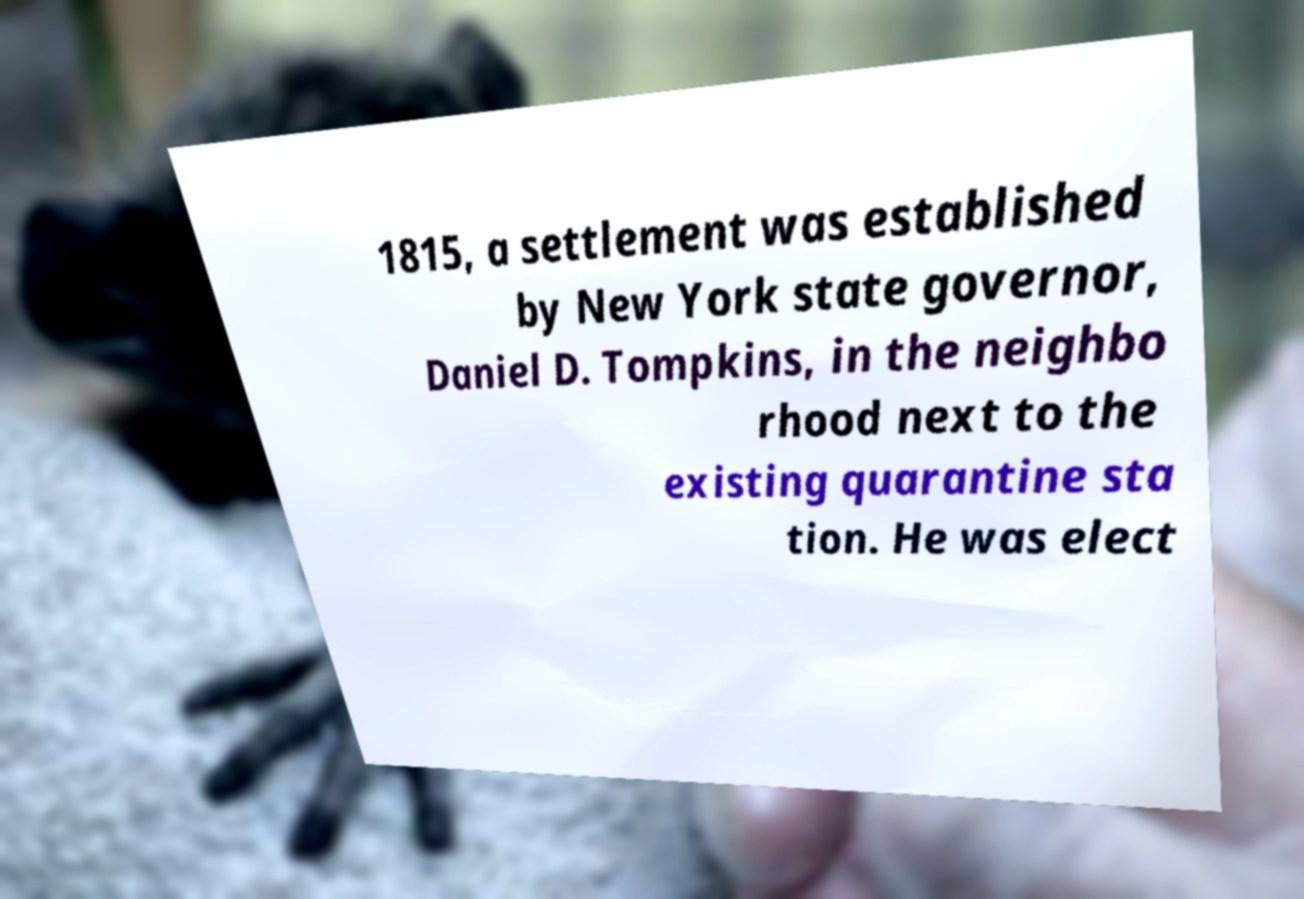There's text embedded in this image that I need extracted. Can you transcribe it verbatim? 1815, a settlement was established by New York state governor, Daniel D. Tompkins, in the neighbo rhood next to the existing quarantine sta tion. He was elect 